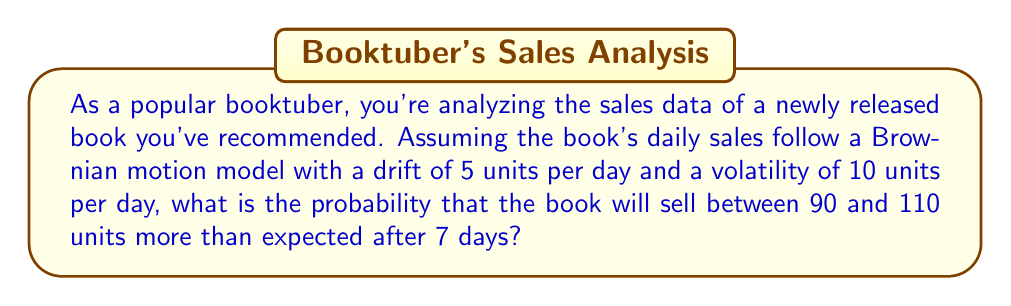Provide a solution to this math problem. Let's approach this step-by-step:

1) In Brownian motion, the change in sales over a time period $t$ follows a normal distribution:

   $\Delta S_t \sim N(\mu t, \sigma^2 t)$

   where $\mu$ is the drift and $\sigma$ is the volatility.

2) Given:
   - Drift $\mu = 5$ units/day
   - Volatility $\sigma = 10$ units/day
   - Time period $t = 7$ days

3) The expected change in sales after 7 days is:
   
   $E[\Delta S_7] = \mu t = 5 \times 7 = 35$ units

4) The variance of the change in sales after 7 days is:
   
   $Var[\Delta S_7] = \sigma^2 t = 10^2 \times 7 = 700$ units²

5) The standard deviation is:
   
   $SD[\Delta S_7] = \sqrt{700} \approx 26.46$ units

6) We want to find the probability that sales are between 90 and 110 units more than expected.
   This means we're looking for:
   
   $P(90 < \Delta S_7 - 35 < 110)$

7) Standardizing this:

   $P(\frac{90 - 35}{26.46} < Z < \frac{110 - 35}{26.46})$

   $P(2.08 < Z < 2.83)$

8) Using the standard normal distribution table or calculator:

   $P(Z < 2.83) - P(Z < 2.08) = 0.9977 - 0.9812 = 0.0165$

Therefore, the probability is approximately 0.0165 or 1.65%.
Answer: 0.0165 (or 1.65%) 